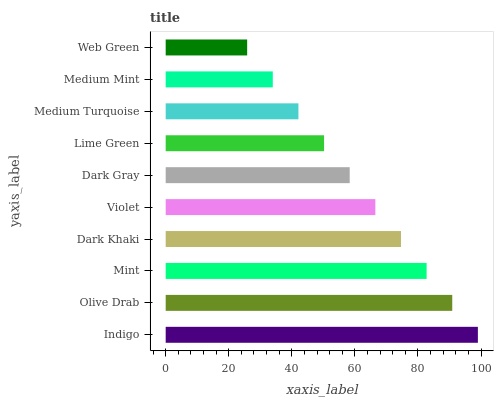Is Web Green the minimum?
Answer yes or no. Yes. Is Indigo the maximum?
Answer yes or no. Yes. Is Olive Drab the minimum?
Answer yes or no. No. Is Olive Drab the maximum?
Answer yes or no. No. Is Indigo greater than Olive Drab?
Answer yes or no. Yes. Is Olive Drab less than Indigo?
Answer yes or no. Yes. Is Olive Drab greater than Indigo?
Answer yes or no. No. Is Indigo less than Olive Drab?
Answer yes or no. No. Is Violet the high median?
Answer yes or no. Yes. Is Dark Gray the low median?
Answer yes or no. Yes. Is Dark Khaki the high median?
Answer yes or no. No. Is Indigo the low median?
Answer yes or no. No. 